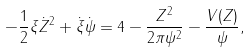<formula> <loc_0><loc_0><loc_500><loc_500>- \frac { 1 } { 2 } \xi \dot { Z } ^ { 2 } + \dot { \xi } \dot { \psi } = 4 - \frac { Z ^ { 2 } } { 2 \pi \psi ^ { 2 } } - \frac { V ( Z ) } { \psi } ,</formula> 